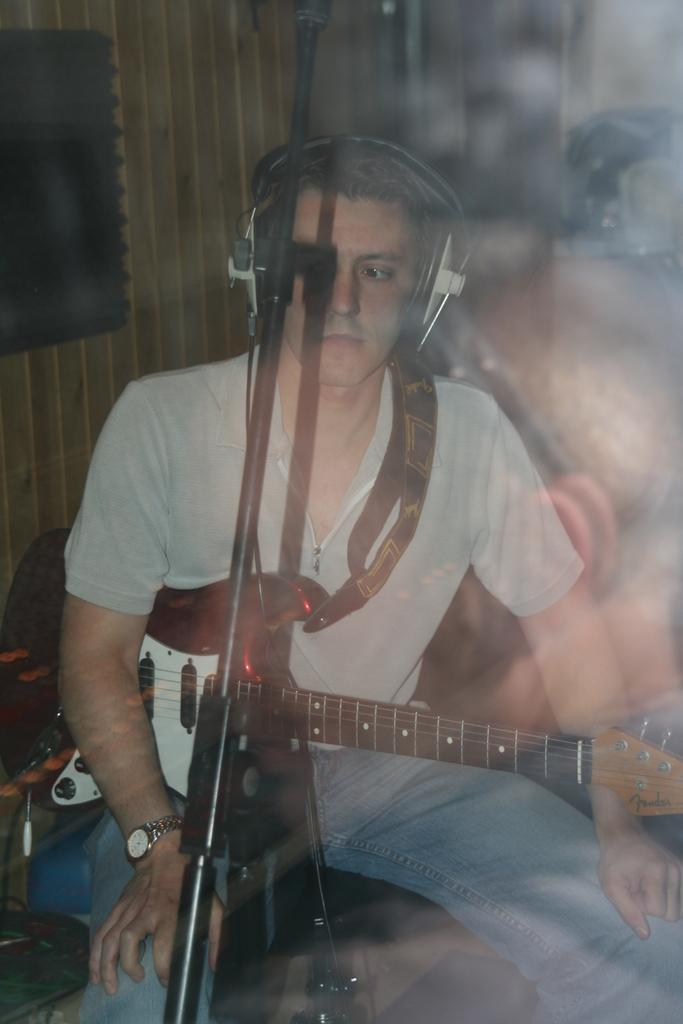Who is present in the image? There is a man in the image. What is the man doing in the image? The man is sitting in the image. What object is the man holding? The man is holding a guitar in the image. What is in front of the man? There is a stand in front of the man in the image. What can be seen in the background of the image? There is a wooden wall in the background of the image. What type of plantation is visible in the image? There is no plantation present in the image; it features a man sitting with a guitar and a wooden wall in the background. 